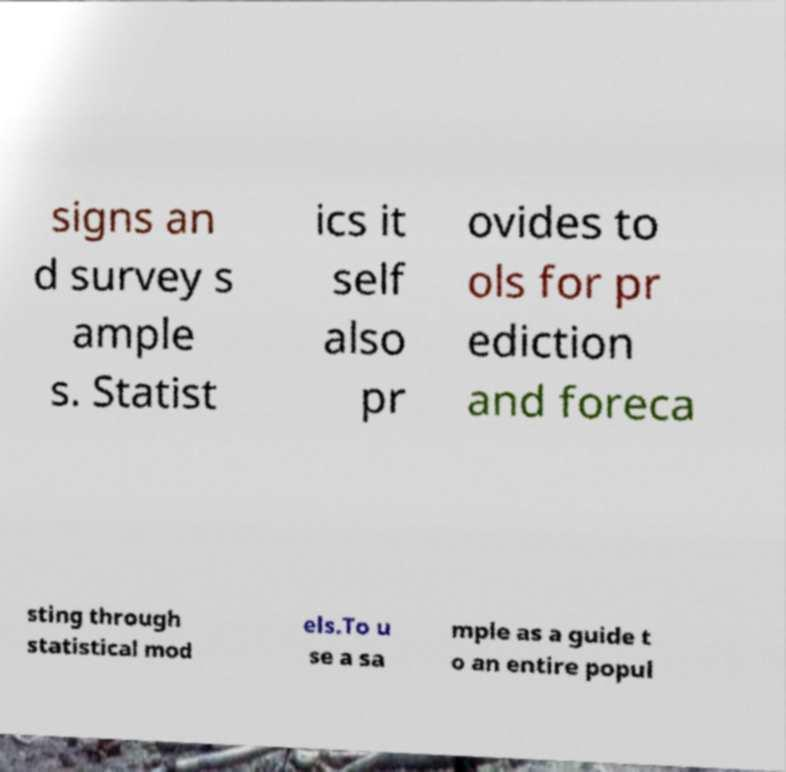Please read and relay the text visible in this image. What does it say? signs an d survey s ample s. Statist ics it self also pr ovides to ols for pr ediction and foreca sting through statistical mod els.To u se a sa mple as a guide t o an entire popul 